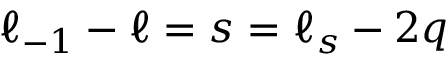<formula> <loc_0><loc_0><loc_500><loc_500>\ell _ { - 1 } - \ell = s = \ell _ { s } - 2 q</formula> 